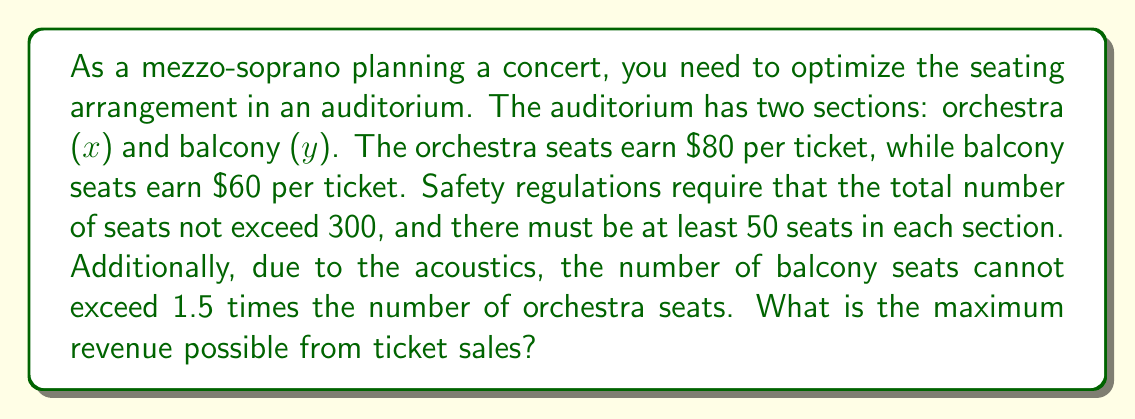Could you help me with this problem? Let's approach this step-by-step using linear programming:

1) Define variables:
   $x$ = number of orchestra seats
   $y$ = number of balcony seats

2) Objective function (revenue):
   Maximize $Z = 80x + 60y$

3) Constraints:
   a) Total seats: $x + y \leq 300$
   b) Minimum seats in each section: $x \geq 50$ and $y \geq 50$
   c) Balcony seats limit: $y \leq 1.5x$

4) Non-negativity: $x \geq 0$ and $y \geq 0$

5) Plot the constraints:
   [asy]
   import graph;
   size(200);
   xaxis("x", 0, 300, Arrow);
   yaxis("y", 0, 300, Arrow);
   draw((0,300)--(300,0), blue);
   draw((50,0)--(50,300), red);
   draw((0,50)--(300,50), red);
   draw((0,0)--(200,300), green);
   label("x+y=300", (150,150), blue);
   label("x=50", (55,150), red);
   label("y=50", (150,55), red);
   label("y=1.5x", (100,150), green);
   dot((120,180));
   label("(120,180)", (125,185));
   [/asy]

6) The feasible region is the area bounded by these lines. The optimal solution will be at one of the corner points.

7) Corner points:
   (50, 50), (50, 75), (120, 180), (200, 100)

8) Evaluate the objective function at each point:
   (50, 50):   $Z = 80(50) + 60(50) = 7000$
   (50, 75):   $Z = 80(50) + 60(75) = 8500$
   (120, 180): $Z = 80(120) + 60(180) = 20400$
   (200, 100): $Z = 80(200) + 60(100) = 22000$

9) The maximum revenue is achieved at (200, 100), which gives $22000.
Answer: $22000 